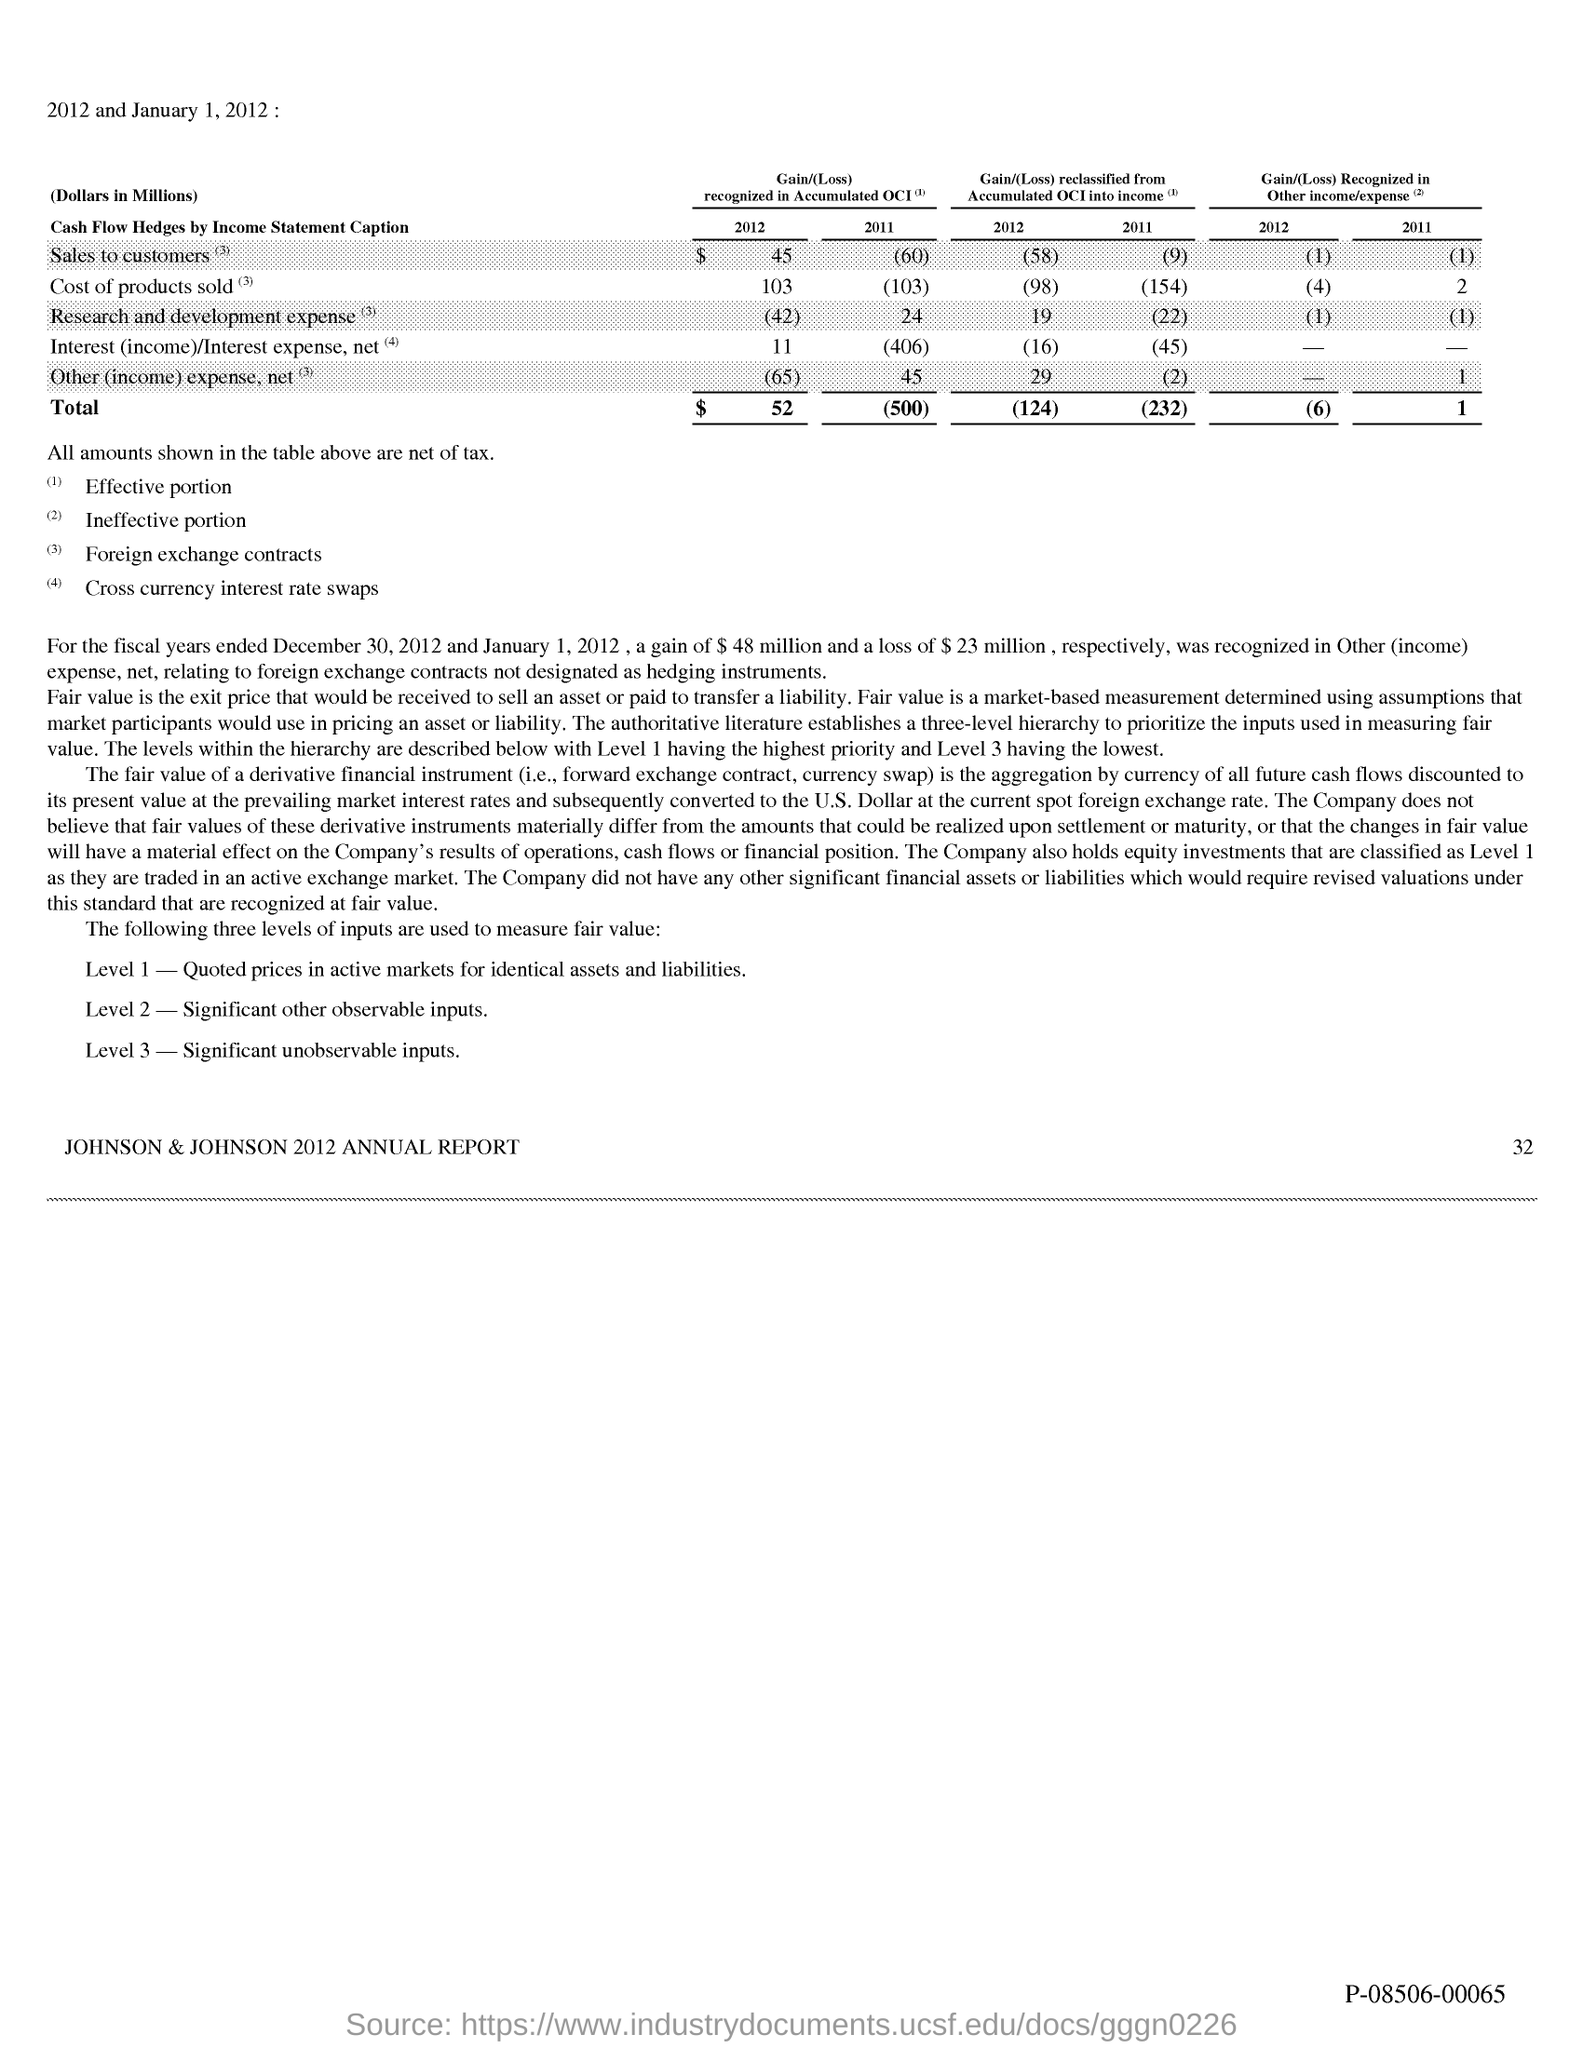What is the Level 1 input to measure fair value?
Ensure brevity in your answer.  Quoted prices in active markets for identical assets and liabilities. What is the Level 2 input to measure fair value?
Your answer should be very brief. Significant other observable inputs. What is the Level 3 input to measure fair value?
Give a very brief answer. Significant unobservable inputs. What does the company hold?
Offer a very short reply. Equity investments. Which level has the highest priority?
Offer a terse response. Level 1. Which level has the lowest priority?
Give a very brief answer. Level 3. 